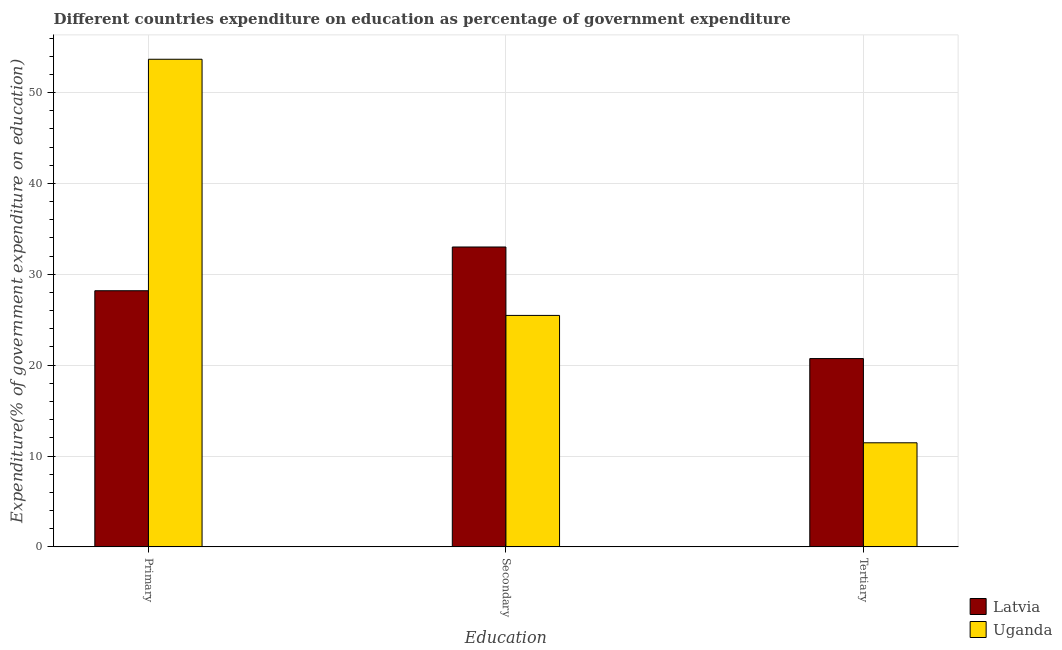Are the number of bars per tick equal to the number of legend labels?
Provide a short and direct response. Yes. Are the number of bars on each tick of the X-axis equal?
Your answer should be very brief. Yes. What is the label of the 3rd group of bars from the left?
Your answer should be compact. Tertiary. What is the expenditure on primary education in Latvia?
Offer a very short reply. 28.19. Across all countries, what is the maximum expenditure on secondary education?
Your response must be concise. 33. Across all countries, what is the minimum expenditure on tertiary education?
Your response must be concise. 11.45. In which country was the expenditure on secondary education maximum?
Provide a succinct answer. Latvia. In which country was the expenditure on secondary education minimum?
Provide a succinct answer. Uganda. What is the total expenditure on primary education in the graph?
Your answer should be compact. 81.86. What is the difference between the expenditure on tertiary education in Uganda and that in Latvia?
Make the answer very short. -9.27. What is the difference between the expenditure on primary education in Latvia and the expenditure on tertiary education in Uganda?
Ensure brevity in your answer.  16.74. What is the average expenditure on tertiary education per country?
Offer a terse response. 16.09. What is the difference between the expenditure on secondary education and expenditure on tertiary education in Uganda?
Your response must be concise. 14.02. In how many countries, is the expenditure on secondary education greater than 16 %?
Offer a very short reply. 2. What is the ratio of the expenditure on primary education in Latvia to that in Uganda?
Ensure brevity in your answer.  0.53. What is the difference between the highest and the second highest expenditure on primary education?
Offer a very short reply. 25.48. What is the difference between the highest and the lowest expenditure on tertiary education?
Give a very brief answer. 9.27. In how many countries, is the expenditure on tertiary education greater than the average expenditure on tertiary education taken over all countries?
Make the answer very short. 1. What does the 1st bar from the left in Secondary represents?
Keep it short and to the point. Latvia. What does the 1st bar from the right in Secondary represents?
Offer a very short reply. Uganda. Is it the case that in every country, the sum of the expenditure on primary education and expenditure on secondary education is greater than the expenditure on tertiary education?
Ensure brevity in your answer.  Yes. How many bars are there?
Provide a succinct answer. 6. Are all the bars in the graph horizontal?
Your answer should be compact. No. What is the difference between two consecutive major ticks on the Y-axis?
Your answer should be compact. 10. Are the values on the major ticks of Y-axis written in scientific E-notation?
Keep it short and to the point. No. Does the graph contain grids?
Give a very brief answer. Yes. How many legend labels are there?
Your answer should be compact. 2. How are the legend labels stacked?
Offer a very short reply. Vertical. What is the title of the graph?
Your answer should be compact. Different countries expenditure on education as percentage of government expenditure. Does "St. Martin (French part)" appear as one of the legend labels in the graph?
Keep it short and to the point. No. What is the label or title of the X-axis?
Your answer should be compact. Education. What is the label or title of the Y-axis?
Make the answer very short. Expenditure(% of government expenditure on education). What is the Expenditure(% of government expenditure on education) in Latvia in Primary?
Offer a very short reply. 28.19. What is the Expenditure(% of government expenditure on education) of Uganda in Primary?
Give a very brief answer. 53.67. What is the Expenditure(% of government expenditure on education) of Latvia in Secondary?
Give a very brief answer. 33. What is the Expenditure(% of government expenditure on education) in Uganda in Secondary?
Offer a very short reply. 25.47. What is the Expenditure(% of government expenditure on education) in Latvia in Tertiary?
Offer a terse response. 20.72. What is the Expenditure(% of government expenditure on education) of Uganda in Tertiary?
Provide a short and direct response. 11.45. Across all Education, what is the maximum Expenditure(% of government expenditure on education) in Latvia?
Keep it short and to the point. 33. Across all Education, what is the maximum Expenditure(% of government expenditure on education) of Uganda?
Offer a terse response. 53.67. Across all Education, what is the minimum Expenditure(% of government expenditure on education) in Latvia?
Provide a short and direct response. 20.72. Across all Education, what is the minimum Expenditure(% of government expenditure on education) of Uganda?
Give a very brief answer. 11.45. What is the total Expenditure(% of government expenditure on education) in Latvia in the graph?
Ensure brevity in your answer.  81.92. What is the total Expenditure(% of government expenditure on education) in Uganda in the graph?
Your response must be concise. 90.6. What is the difference between the Expenditure(% of government expenditure on education) of Latvia in Primary and that in Secondary?
Offer a very short reply. -4.81. What is the difference between the Expenditure(% of government expenditure on education) of Uganda in Primary and that in Secondary?
Your response must be concise. 28.2. What is the difference between the Expenditure(% of government expenditure on education) in Latvia in Primary and that in Tertiary?
Provide a short and direct response. 7.47. What is the difference between the Expenditure(% of government expenditure on education) in Uganda in Primary and that in Tertiary?
Offer a terse response. 42.21. What is the difference between the Expenditure(% of government expenditure on education) of Latvia in Secondary and that in Tertiary?
Keep it short and to the point. 12.28. What is the difference between the Expenditure(% of government expenditure on education) of Uganda in Secondary and that in Tertiary?
Make the answer very short. 14.02. What is the difference between the Expenditure(% of government expenditure on education) in Latvia in Primary and the Expenditure(% of government expenditure on education) in Uganda in Secondary?
Offer a very short reply. 2.72. What is the difference between the Expenditure(% of government expenditure on education) in Latvia in Primary and the Expenditure(% of government expenditure on education) in Uganda in Tertiary?
Offer a very short reply. 16.74. What is the difference between the Expenditure(% of government expenditure on education) in Latvia in Secondary and the Expenditure(% of government expenditure on education) in Uganda in Tertiary?
Provide a short and direct response. 21.55. What is the average Expenditure(% of government expenditure on education) of Latvia per Education?
Your answer should be compact. 27.31. What is the average Expenditure(% of government expenditure on education) in Uganda per Education?
Keep it short and to the point. 30.2. What is the difference between the Expenditure(% of government expenditure on education) in Latvia and Expenditure(% of government expenditure on education) in Uganda in Primary?
Ensure brevity in your answer.  -25.48. What is the difference between the Expenditure(% of government expenditure on education) of Latvia and Expenditure(% of government expenditure on education) of Uganda in Secondary?
Your response must be concise. 7.53. What is the difference between the Expenditure(% of government expenditure on education) in Latvia and Expenditure(% of government expenditure on education) in Uganda in Tertiary?
Offer a terse response. 9.27. What is the ratio of the Expenditure(% of government expenditure on education) in Latvia in Primary to that in Secondary?
Your answer should be very brief. 0.85. What is the ratio of the Expenditure(% of government expenditure on education) of Uganda in Primary to that in Secondary?
Your response must be concise. 2.11. What is the ratio of the Expenditure(% of government expenditure on education) in Latvia in Primary to that in Tertiary?
Your response must be concise. 1.36. What is the ratio of the Expenditure(% of government expenditure on education) of Uganda in Primary to that in Tertiary?
Provide a short and direct response. 4.69. What is the ratio of the Expenditure(% of government expenditure on education) of Latvia in Secondary to that in Tertiary?
Your answer should be very brief. 1.59. What is the ratio of the Expenditure(% of government expenditure on education) in Uganda in Secondary to that in Tertiary?
Your response must be concise. 2.22. What is the difference between the highest and the second highest Expenditure(% of government expenditure on education) of Latvia?
Your answer should be very brief. 4.81. What is the difference between the highest and the second highest Expenditure(% of government expenditure on education) in Uganda?
Provide a succinct answer. 28.2. What is the difference between the highest and the lowest Expenditure(% of government expenditure on education) of Latvia?
Offer a terse response. 12.28. What is the difference between the highest and the lowest Expenditure(% of government expenditure on education) in Uganda?
Your answer should be compact. 42.21. 